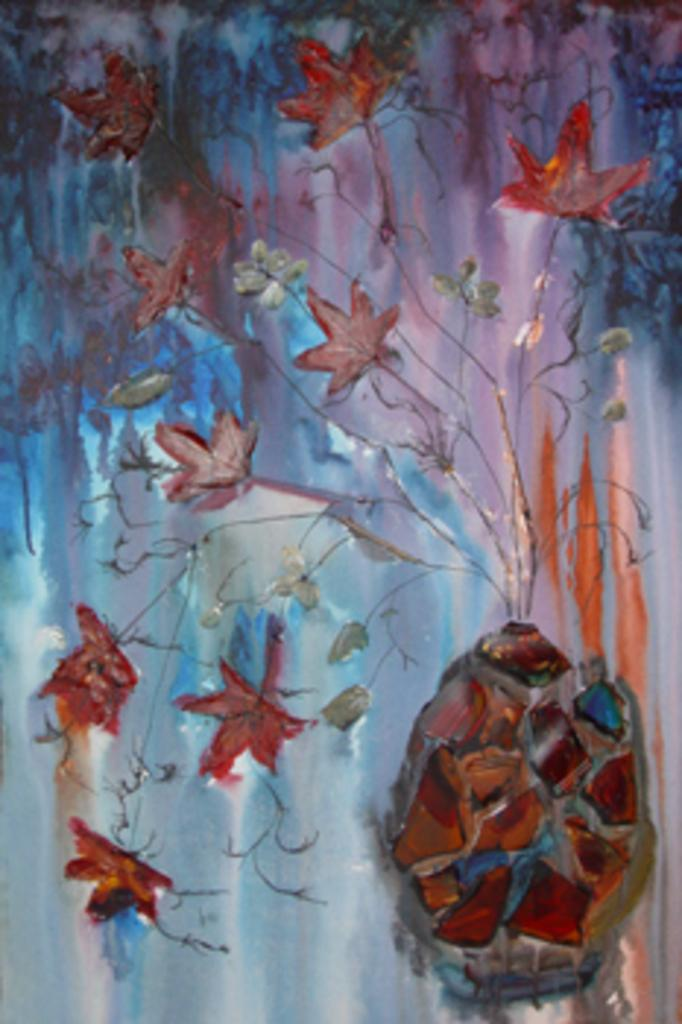What is displayed on the wall in the image? There are paintings on a wall in the image. Can you describe the setting where the paintings are located? The image may have been taken in a hall. What type of tent can be seen in the image? There is no tent present in the image; it features paintings on a wall in a hall. 